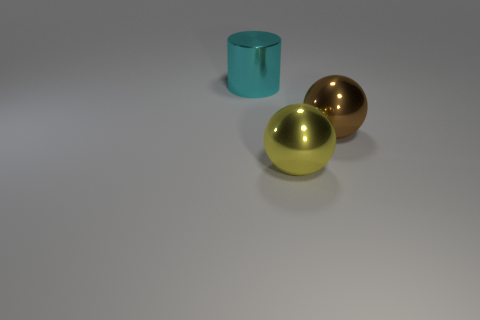What could be the purpose of these objects in the image? While their purpose isn't explicit, they could serve as decorative elements due to their aesthetic appearance, or potentially be part of a set used to study the properties of light and reflection in photography or a physics demonstration. 